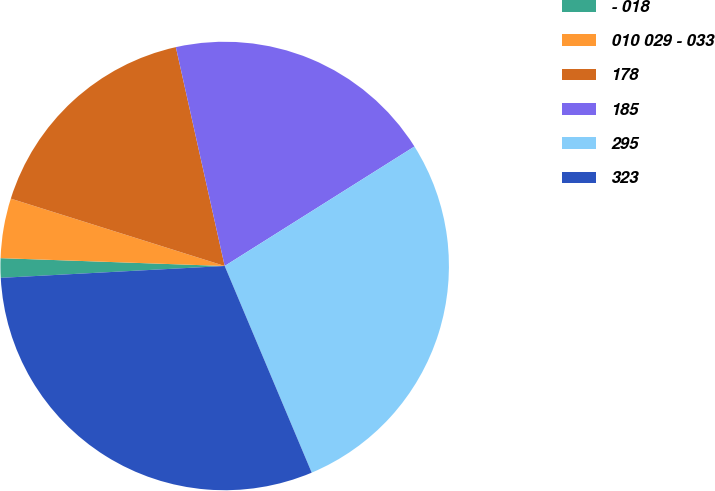Convert chart to OTSL. <chart><loc_0><loc_0><loc_500><loc_500><pie_chart><fcel>- 018<fcel>010 029 - 033<fcel>178<fcel>185<fcel>295<fcel>323<nl><fcel>1.4%<fcel>4.3%<fcel>16.65%<fcel>19.55%<fcel>27.6%<fcel>30.5%<nl></chart> 